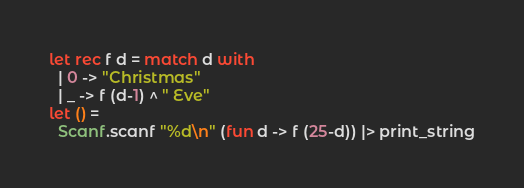Convert code to text. <code><loc_0><loc_0><loc_500><loc_500><_OCaml_>let rec f d = match d with
  | 0 -> "Christmas"
  | _ -> f (d-1) ^ " Eve"
let () =
  Scanf.scanf "%d\n" (fun d -> f (25-d)) |> print_string</code> 